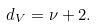Convert formula to latex. <formula><loc_0><loc_0><loc_500><loc_500>d _ { V } = \nu + 2 .</formula> 